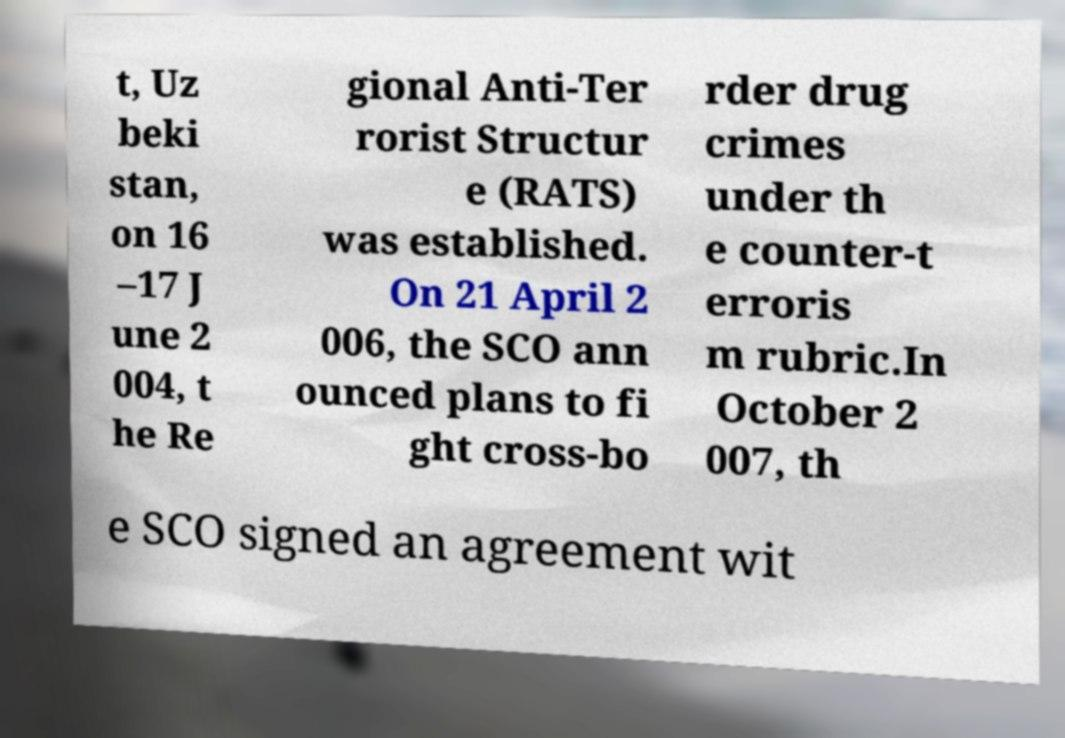For documentation purposes, I need the text within this image transcribed. Could you provide that? t, Uz beki stan, on 16 –17 J une 2 004, t he Re gional Anti-Ter rorist Structur e (RATS) was established. On 21 April 2 006, the SCO ann ounced plans to fi ght cross-bo rder drug crimes under th e counter-t erroris m rubric.In October 2 007, th e SCO signed an agreement wit 